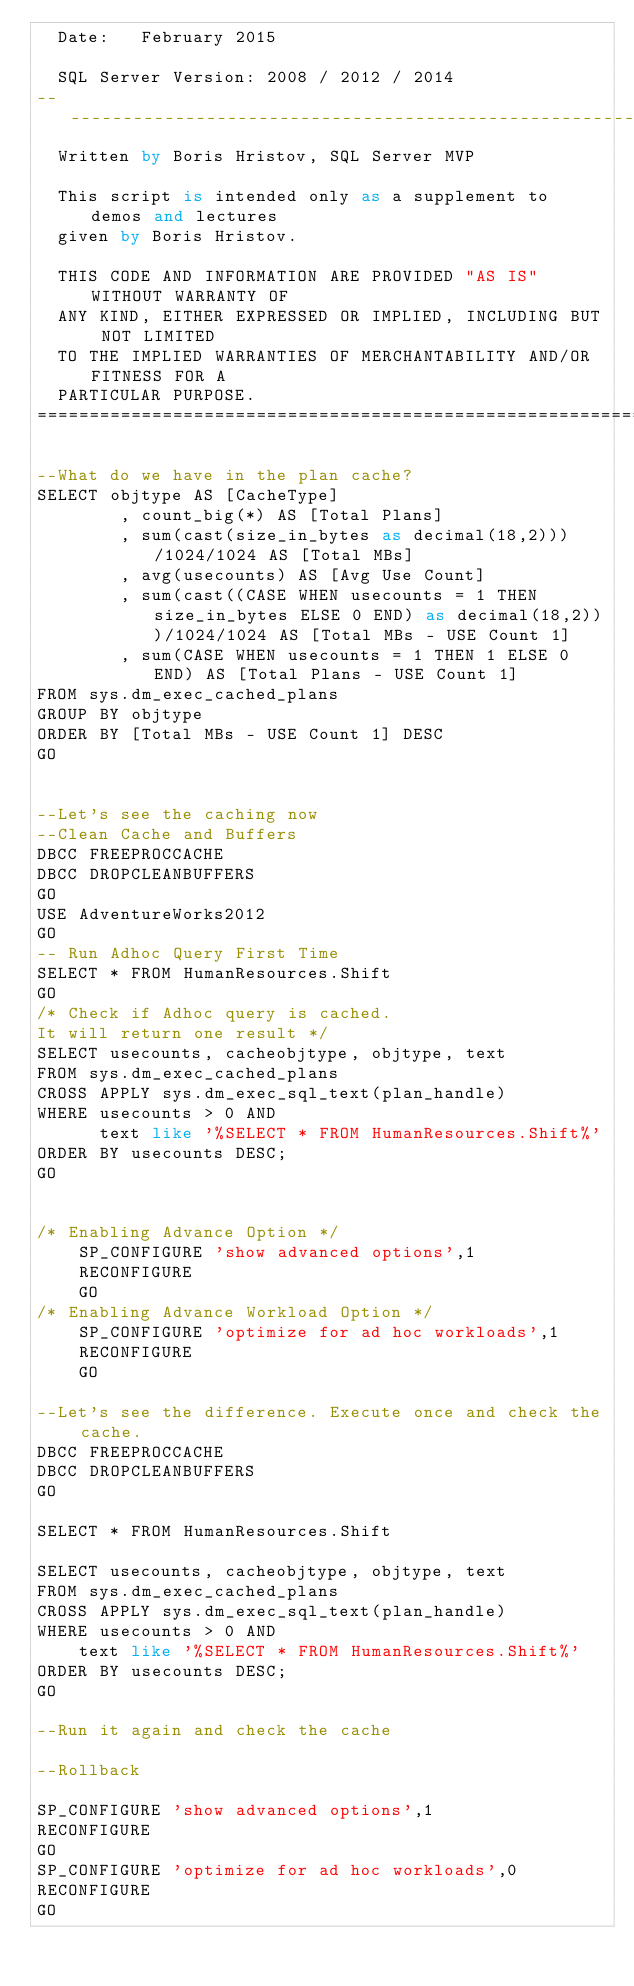<code> <loc_0><loc_0><loc_500><loc_500><_SQL_>	Date:		February 2015

	SQL Server Version: 2008 / 2012 / 2014
------------------------------------------------------------------------------
	Written by Boris Hristov, SQL Server MVP

	This script is intended only as a supplement to demos and lectures
	given by Boris Hristov.  
  
	THIS CODE AND INFORMATION ARE PROVIDED "AS IS" WITHOUT WARRANTY OF 
	ANY KIND, EITHER EXPRESSED OR IMPLIED, INCLUDING BUT NOT LIMITED 
	TO THE IMPLIED WARRANTIES OF MERCHANTABILITY AND/OR FITNESS FOR A
	PARTICULAR PURPOSE.
============================================================================*/

--What do we have in the plan cache?
SELECT objtype AS [CacheType]
        , count_big(*) AS [Total Plans]
        , sum(cast(size_in_bytes as decimal(18,2)))/1024/1024 AS [Total MBs]
        , avg(usecounts) AS [Avg Use Count]
        , sum(cast((CASE WHEN usecounts = 1 THEN size_in_bytes ELSE 0 END) as decimal(18,2)))/1024/1024 AS [Total MBs - USE Count 1]
        , sum(CASE WHEN usecounts = 1 THEN 1 ELSE 0 END) AS [Total Plans - USE Count 1]
FROM sys.dm_exec_cached_plans
GROUP BY objtype
ORDER BY [Total MBs - USE Count 1] DESC
GO


--Let's see the caching now
--Clean Cache and Buffers
DBCC FREEPROCCACHE
DBCC DROPCLEANBUFFERS
GO
USE AdventureWorks2012
GO
-- Run Adhoc Query First Time
SELECT * FROM HumanResources.Shift
GO
/* Check if Adhoc query is cached.
It will return one result */
SELECT usecounts, cacheobjtype, objtype, text 
FROM sys.dm_exec_cached_plans 
CROSS APPLY sys.dm_exec_sql_text(plan_handle) 
WHERE usecounts > 0 AND 
			text like '%SELECT * FROM HumanResources.Shift%'
ORDER BY usecounts DESC;
GO


/* Enabling Advance Option */
    SP_CONFIGURE 'show advanced options',1
    RECONFIGURE
    GO
/* Enabling Advance Workload Option */
    SP_CONFIGURE 'optimize for ad hoc workloads',1
    RECONFIGURE
    GO

--Let's see the difference. Execute once and check the cache.
DBCC FREEPROCCACHE
DBCC DROPCLEANBUFFERS
GO

SELECT * FROM HumanResources.Shift

SELECT usecounts, cacheobjtype, objtype, text 
FROM sys.dm_exec_cached_plans 
CROSS APPLY sys.dm_exec_sql_text(plan_handle) 
WHERE usecounts > 0 AND 
		text like '%SELECT * FROM HumanResources.Shift%'
ORDER BY usecounts DESC;
GO

--Run it again and check the cache

--Rollback

SP_CONFIGURE 'show advanced options',1
RECONFIGURE
GO
SP_CONFIGURE 'optimize for ad hoc workloads',0
RECONFIGURE
GO
</code> 